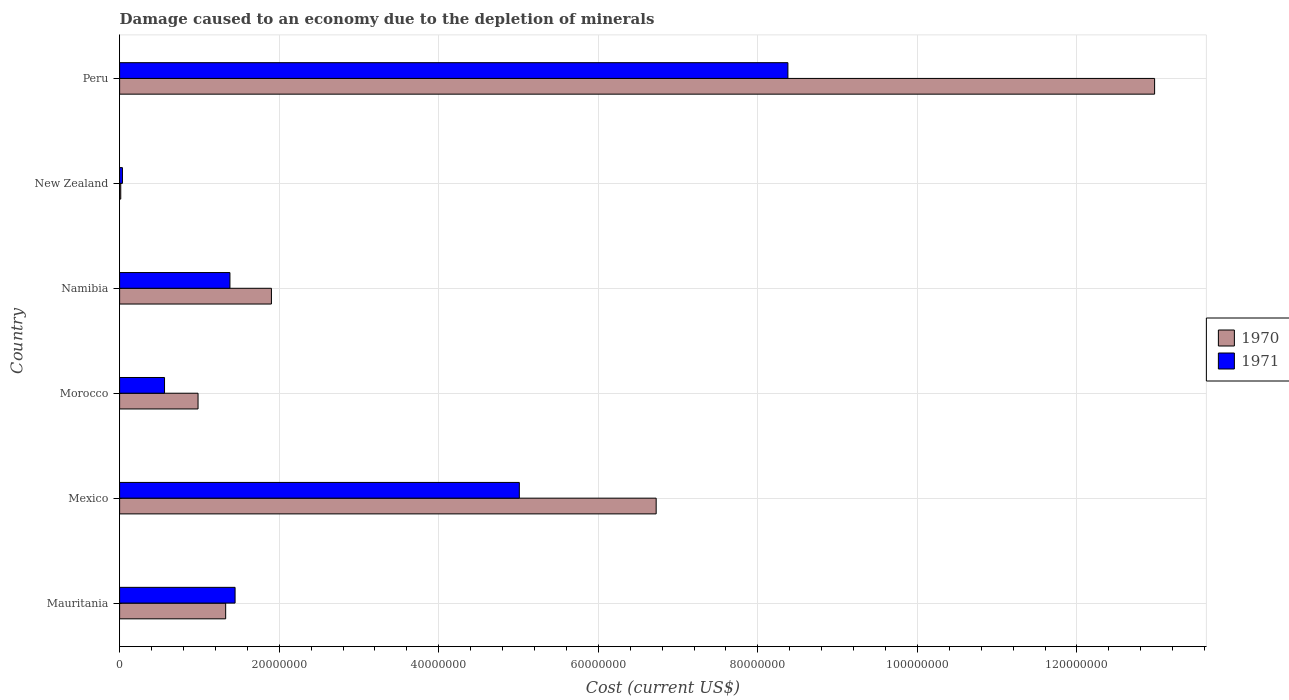How many groups of bars are there?
Keep it short and to the point. 6. Are the number of bars on each tick of the Y-axis equal?
Offer a very short reply. Yes. What is the label of the 6th group of bars from the top?
Give a very brief answer. Mauritania. What is the cost of damage caused due to the depletion of minerals in 1971 in New Zealand?
Give a very brief answer. 3.55e+05. Across all countries, what is the maximum cost of damage caused due to the depletion of minerals in 1971?
Offer a terse response. 8.38e+07. Across all countries, what is the minimum cost of damage caused due to the depletion of minerals in 1971?
Provide a succinct answer. 3.55e+05. In which country was the cost of damage caused due to the depletion of minerals in 1971 minimum?
Offer a terse response. New Zealand. What is the total cost of damage caused due to the depletion of minerals in 1971 in the graph?
Provide a short and direct response. 1.68e+08. What is the difference between the cost of damage caused due to the depletion of minerals in 1970 in Mauritania and that in Peru?
Your response must be concise. -1.16e+08. What is the difference between the cost of damage caused due to the depletion of minerals in 1971 in Namibia and the cost of damage caused due to the depletion of minerals in 1970 in Mexico?
Offer a very short reply. -5.34e+07. What is the average cost of damage caused due to the depletion of minerals in 1971 per country?
Provide a short and direct response. 2.80e+07. What is the difference between the cost of damage caused due to the depletion of minerals in 1971 and cost of damage caused due to the depletion of minerals in 1970 in Morocco?
Keep it short and to the point. -4.20e+06. What is the ratio of the cost of damage caused due to the depletion of minerals in 1971 in Mauritania to that in New Zealand?
Your answer should be very brief. 40.79. Is the cost of damage caused due to the depletion of minerals in 1970 in New Zealand less than that in Peru?
Offer a terse response. Yes. What is the difference between the highest and the second highest cost of damage caused due to the depletion of minerals in 1971?
Keep it short and to the point. 3.37e+07. What is the difference between the highest and the lowest cost of damage caused due to the depletion of minerals in 1971?
Ensure brevity in your answer.  8.34e+07. Is the sum of the cost of damage caused due to the depletion of minerals in 1970 in Mexico and New Zealand greater than the maximum cost of damage caused due to the depletion of minerals in 1971 across all countries?
Give a very brief answer. No. What does the 1st bar from the bottom in Morocco represents?
Provide a short and direct response. 1970. Are all the bars in the graph horizontal?
Your answer should be compact. Yes. How many countries are there in the graph?
Keep it short and to the point. 6. What is the difference between two consecutive major ticks on the X-axis?
Ensure brevity in your answer.  2.00e+07. Where does the legend appear in the graph?
Provide a succinct answer. Center right. How are the legend labels stacked?
Ensure brevity in your answer.  Vertical. What is the title of the graph?
Provide a short and direct response. Damage caused to an economy due to the depletion of minerals. Does "1986" appear as one of the legend labels in the graph?
Your answer should be very brief. No. What is the label or title of the X-axis?
Give a very brief answer. Cost (current US$). What is the Cost (current US$) in 1970 in Mauritania?
Make the answer very short. 1.33e+07. What is the Cost (current US$) of 1971 in Mauritania?
Provide a succinct answer. 1.45e+07. What is the Cost (current US$) in 1970 in Mexico?
Offer a terse response. 6.73e+07. What is the Cost (current US$) in 1971 in Mexico?
Provide a succinct answer. 5.01e+07. What is the Cost (current US$) in 1970 in Morocco?
Your answer should be very brief. 9.83e+06. What is the Cost (current US$) in 1971 in Morocco?
Offer a very short reply. 5.63e+06. What is the Cost (current US$) of 1970 in Namibia?
Your response must be concise. 1.90e+07. What is the Cost (current US$) in 1971 in Namibia?
Ensure brevity in your answer.  1.38e+07. What is the Cost (current US$) in 1970 in New Zealand?
Provide a short and direct response. 1.43e+05. What is the Cost (current US$) of 1971 in New Zealand?
Give a very brief answer. 3.55e+05. What is the Cost (current US$) in 1970 in Peru?
Provide a short and direct response. 1.30e+08. What is the Cost (current US$) in 1971 in Peru?
Ensure brevity in your answer.  8.38e+07. Across all countries, what is the maximum Cost (current US$) of 1970?
Your answer should be very brief. 1.30e+08. Across all countries, what is the maximum Cost (current US$) in 1971?
Offer a terse response. 8.38e+07. Across all countries, what is the minimum Cost (current US$) in 1970?
Make the answer very short. 1.43e+05. Across all countries, what is the minimum Cost (current US$) in 1971?
Your answer should be very brief. 3.55e+05. What is the total Cost (current US$) in 1970 in the graph?
Offer a very short reply. 2.39e+08. What is the total Cost (current US$) in 1971 in the graph?
Offer a terse response. 1.68e+08. What is the difference between the Cost (current US$) in 1970 in Mauritania and that in Mexico?
Your answer should be compact. -5.40e+07. What is the difference between the Cost (current US$) in 1971 in Mauritania and that in Mexico?
Make the answer very short. -3.56e+07. What is the difference between the Cost (current US$) in 1970 in Mauritania and that in Morocco?
Give a very brief answer. 3.46e+06. What is the difference between the Cost (current US$) of 1971 in Mauritania and that in Morocco?
Make the answer very short. 8.84e+06. What is the difference between the Cost (current US$) in 1970 in Mauritania and that in Namibia?
Your answer should be very brief. -5.74e+06. What is the difference between the Cost (current US$) in 1971 in Mauritania and that in Namibia?
Provide a succinct answer. 6.44e+05. What is the difference between the Cost (current US$) in 1970 in Mauritania and that in New Zealand?
Ensure brevity in your answer.  1.32e+07. What is the difference between the Cost (current US$) in 1971 in Mauritania and that in New Zealand?
Give a very brief answer. 1.41e+07. What is the difference between the Cost (current US$) in 1970 in Mauritania and that in Peru?
Your answer should be very brief. -1.16e+08. What is the difference between the Cost (current US$) of 1971 in Mauritania and that in Peru?
Give a very brief answer. -6.93e+07. What is the difference between the Cost (current US$) of 1970 in Mexico and that in Morocco?
Keep it short and to the point. 5.74e+07. What is the difference between the Cost (current US$) in 1971 in Mexico and that in Morocco?
Provide a succinct answer. 4.45e+07. What is the difference between the Cost (current US$) of 1970 in Mexico and that in Namibia?
Your answer should be very brief. 4.82e+07. What is the difference between the Cost (current US$) of 1971 in Mexico and that in Namibia?
Offer a terse response. 3.63e+07. What is the difference between the Cost (current US$) in 1970 in Mexico and that in New Zealand?
Your answer should be very brief. 6.71e+07. What is the difference between the Cost (current US$) in 1971 in Mexico and that in New Zealand?
Make the answer very short. 4.97e+07. What is the difference between the Cost (current US$) of 1970 in Mexico and that in Peru?
Offer a terse response. -6.25e+07. What is the difference between the Cost (current US$) of 1971 in Mexico and that in Peru?
Make the answer very short. -3.37e+07. What is the difference between the Cost (current US$) in 1970 in Morocco and that in Namibia?
Offer a terse response. -9.20e+06. What is the difference between the Cost (current US$) in 1971 in Morocco and that in Namibia?
Your answer should be compact. -8.20e+06. What is the difference between the Cost (current US$) of 1970 in Morocco and that in New Zealand?
Provide a short and direct response. 9.69e+06. What is the difference between the Cost (current US$) in 1971 in Morocco and that in New Zealand?
Provide a short and direct response. 5.28e+06. What is the difference between the Cost (current US$) in 1970 in Morocco and that in Peru?
Make the answer very short. -1.20e+08. What is the difference between the Cost (current US$) in 1971 in Morocco and that in Peru?
Keep it short and to the point. -7.81e+07. What is the difference between the Cost (current US$) of 1970 in Namibia and that in New Zealand?
Your answer should be very brief. 1.89e+07. What is the difference between the Cost (current US$) in 1971 in Namibia and that in New Zealand?
Give a very brief answer. 1.35e+07. What is the difference between the Cost (current US$) of 1970 in Namibia and that in Peru?
Your response must be concise. -1.11e+08. What is the difference between the Cost (current US$) in 1971 in Namibia and that in Peru?
Ensure brevity in your answer.  -6.99e+07. What is the difference between the Cost (current US$) of 1970 in New Zealand and that in Peru?
Offer a terse response. -1.30e+08. What is the difference between the Cost (current US$) of 1971 in New Zealand and that in Peru?
Your response must be concise. -8.34e+07. What is the difference between the Cost (current US$) in 1970 in Mauritania and the Cost (current US$) in 1971 in Mexico?
Your answer should be very brief. -3.68e+07. What is the difference between the Cost (current US$) of 1970 in Mauritania and the Cost (current US$) of 1971 in Morocco?
Give a very brief answer. 7.66e+06. What is the difference between the Cost (current US$) in 1970 in Mauritania and the Cost (current US$) in 1971 in Namibia?
Give a very brief answer. -5.35e+05. What is the difference between the Cost (current US$) of 1970 in Mauritania and the Cost (current US$) of 1971 in New Zealand?
Your response must be concise. 1.29e+07. What is the difference between the Cost (current US$) of 1970 in Mauritania and the Cost (current US$) of 1971 in Peru?
Offer a very short reply. -7.05e+07. What is the difference between the Cost (current US$) in 1970 in Mexico and the Cost (current US$) in 1971 in Morocco?
Provide a succinct answer. 6.16e+07. What is the difference between the Cost (current US$) of 1970 in Mexico and the Cost (current US$) of 1971 in Namibia?
Make the answer very short. 5.34e+07. What is the difference between the Cost (current US$) in 1970 in Mexico and the Cost (current US$) in 1971 in New Zealand?
Make the answer very short. 6.69e+07. What is the difference between the Cost (current US$) of 1970 in Mexico and the Cost (current US$) of 1971 in Peru?
Make the answer very short. -1.65e+07. What is the difference between the Cost (current US$) of 1970 in Morocco and the Cost (current US$) of 1971 in Namibia?
Your answer should be compact. -4.00e+06. What is the difference between the Cost (current US$) in 1970 in Morocco and the Cost (current US$) in 1971 in New Zealand?
Keep it short and to the point. 9.48e+06. What is the difference between the Cost (current US$) in 1970 in Morocco and the Cost (current US$) in 1971 in Peru?
Your answer should be very brief. -7.39e+07. What is the difference between the Cost (current US$) of 1970 in Namibia and the Cost (current US$) of 1971 in New Zealand?
Your answer should be very brief. 1.87e+07. What is the difference between the Cost (current US$) of 1970 in Namibia and the Cost (current US$) of 1971 in Peru?
Provide a short and direct response. -6.47e+07. What is the difference between the Cost (current US$) in 1970 in New Zealand and the Cost (current US$) in 1971 in Peru?
Offer a very short reply. -8.36e+07. What is the average Cost (current US$) of 1970 per country?
Your response must be concise. 3.99e+07. What is the average Cost (current US$) in 1971 per country?
Provide a succinct answer. 2.80e+07. What is the difference between the Cost (current US$) in 1970 and Cost (current US$) in 1971 in Mauritania?
Your answer should be very brief. -1.18e+06. What is the difference between the Cost (current US$) in 1970 and Cost (current US$) in 1971 in Mexico?
Give a very brief answer. 1.72e+07. What is the difference between the Cost (current US$) in 1970 and Cost (current US$) in 1971 in Morocco?
Keep it short and to the point. 4.20e+06. What is the difference between the Cost (current US$) in 1970 and Cost (current US$) in 1971 in Namibia?
Give a very brief answer. 5.20e+06. What is the difference between the Cost (current US$) in 1970 and Cost (current US$) in 1971 in New Zealand?
Offer a very short reply. -2.11e+05. What is the difference between the Cost (current US$) in 1970 and Cost (current US$) in 1971 in Peru?
Offer a terse response. 4.60e+07. What is the ratio of the Cost (current US$) in 1970 in Mauritania to that in Mexico?
Make the answer very short. 0.2. What is the ratio of the Cost (current US$) of 1971 in Mauritania to that in Mexico?
Your response must be concise. 0.29. What is the ratio of the Cost (current US$) in 1970 in Mauritania to that in Morocco?
Provide a succinct answer. 1.35. What is the ratio of the Cost (current US$) of 1971 in Mauritania to that in Morocco?
Offer a very short reply. 2.57. What is the ratio of the Cost (current US$) in 1970 in Mauritania to that in Namibia?
Your answer should be very brief. 0.7. What is the ratio of the Cost (current US$) of 1971 in Mauritania to that in Namibia?
Your answer should be compact. 1.05. What is the ratio of the Cost (current US$) in 1970 in Mauritania to that in New Zealand?
Your response must be concise. 92.74. What is the ratio of the Cost (current US$) of 1971 in Mauritania to that in New Zealand?
Give a very brief answer. 40.79. What is the ratio of the Cost (current US$) in 1970 in Mauritania to that in Peru?
Your answer should be compact. 0.1. What is the ratio of the Cost (current US$) in 1971 in Mauritania to that in Peru?
Offer a very short reply. 0.17. What is the ratio of the Cost (current US$) of 1970 in Mexico to that in Morocco?
Your answer should be very brief. 6.84. What is the ratio of the Cost (current US$) of 1971 in Mexico to that in Morocco?
Keep it short and to the point. 8.9. What is the ratio of the Cost (current US$) of 1970 in Mexico to that in Namibia?
Make the answer very short. 3.53. What is the ratio of the Cost (current US$) of 1971 in Mexico to that in Namibia?
Offer a terse response. 3.62. What is the ratio of the Cost (current US$) in 1970 in Mexico to that in New Zealand?
Your answer should be compact. 469.14. What is the ratio of the Cost (current US$) of 1971 in Mexico to that in New Zealand?
Offer a terse response. 141.19. What is the ratio of the Cost (current US$) of 1970 in Mexico to that in Peru?
Your answer should be very brief. 0.52. What is the ratio of the Cost (current US$) of 1971 in Mexico to that in Peru?
Your response must be concise. 0.6. What is the ratio of the Cost (current US$) of 1970 in Morocco to that in Namibia?
Offer a terse response. 0.52. What is the ratio of the Cost (current US$) of 1971 in Morocco to that in Namibia?
Offer a terse response. 0.41. What is the ratio of the Cost (current US$) of 1970 in Morocco to that in New Zealand?
Offer a terse response. 68.59. What is the ratio of the Cost (current US$) in 1971 in Morocco to that in New Zealand?
Offer a very short reply. 15.87. What is the ratio of the Cost (current US$) of 1970 in Morocco to that in Peru?
Keep it short and to the point. 0.08. What is the ratio of the Cost (current US$) in 1971 in Morocco to that in Peru?
Make the answer very short. 0.07. What is the ratio of the Cost (current US$) in 1970 in Namibia to that in New Zealand?
Offer a terse response. 132.75. What is the ratio of the Cost (current US$) in 1971 in Namibia to that in New Zealand?
Ensure brevity in your answer.  38.97. What is the ratio of the Cost (current US$) in 1970 in Namibia to that in Peru?
Your answer should be compact. 0.15. What is the ratio of the Cost (current US$) of 1971 in Namibia to that in Peru?
Offer a very short reply. 0.17. What is the ratio of the Cost (current US$) in 1970 in New Zealand to that in Peru?
Ensure brevity in your answer.  0. What is the ratio of the Cost (current US$) in 1971 in New Zealand to that in Peru?
Make the answer very short. 0. What is the difference between the highest and the second highest Cost (current US$) of 1970?
Give a very brief answer. 6.25e+07. What is the difference between the highest and the second highest Cost (current US$) in 1971?
Give a very brief answer. 3.37e+07. What is the difference between the highest and the lowest Cost (current US$) of 1970?
Make the answer very short. 1.30e+08. What is the difference between the highest and the lowest Cost (current US$) in 1971?
Offer a terse response. 8.34e+07. 